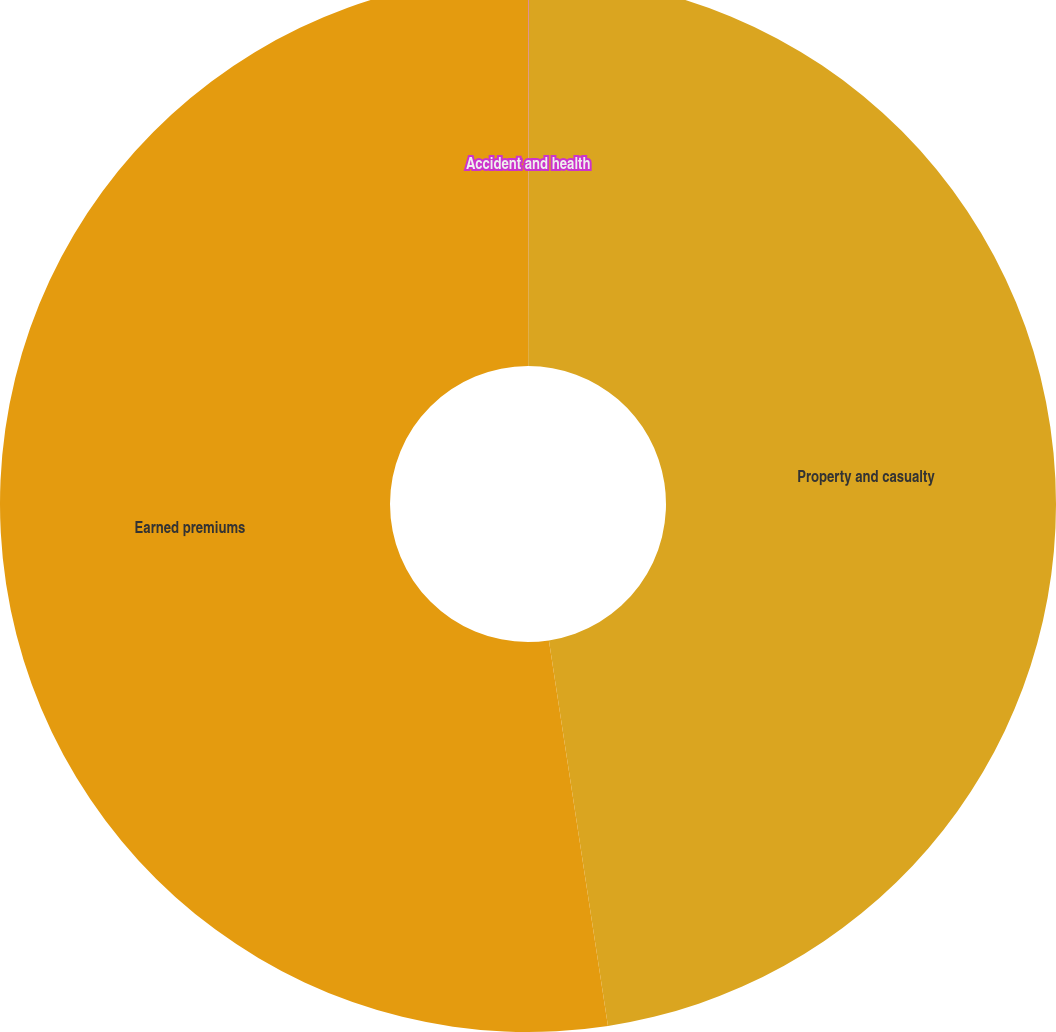Convert chart. <chart><loc_0><loc_0><loc_500><loc_500><pie_chart><fcel>Accident and health<fcel>Property and casualty<fcel>Earned premiums<nl><fcel>0.02%<fcel>47.56%<fcel>52.42%<nl></chart> 